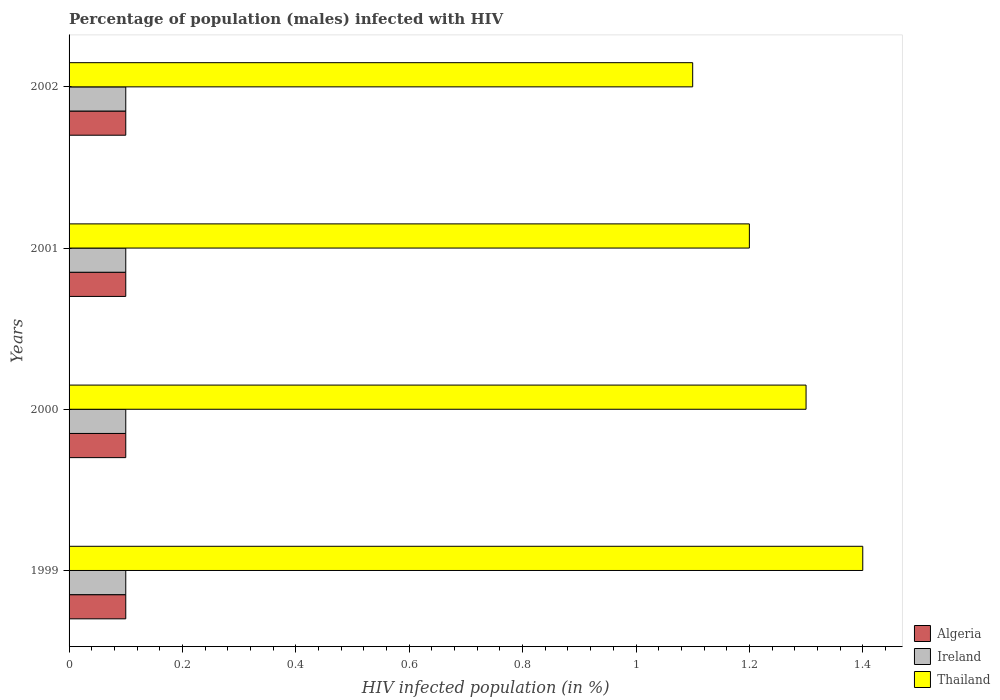How many groups of bars are there?
Ensure brevity in your answer.  4. How many bars are there on the 1st tick from the bottom?
Offer a terse response. 3. What is the label of the 2nd group of bars from the top?
Keep it short and to the point. 2001. Across all years, what is the minimum percentage of HIV infected male population in Algeria?
Your response must be concise. 0.1. In which year was the percentage of HIV infected male population in Thailand minimum?
Give a very brief answer. 2002. What is the difference between the percentage of HIV infected male population in Algeria in 2000 and the percentage of HIV infected male population in Ireland in 2001?
Give a very brief answer. 0. What is the ratio of the percentage of HIV infected male population in Thailand in 1999 to that in 2002?
Your answer should be compact. 1.27. Is the percentage of HIV infected male population in Ireland in 1999 less than that in 2002?
Provide a succinct answer. No. What is the difference between the highest and the lowest percentage of HIV infected male population in Ireland?
Give a very brief answer. 0. In how many years, is the percentage of HIV infected male population in Thailand greater than the average percentage of HIV infected male population in Thailand taken over all years?
Offer a terse response. 2. What does the 2nd bar from the top in 2001 represents?
Offer a terse response. Ireland. What does the 3rd bar from the bottom in 2001 represents?
Provide a succinct answer. Thailand. Is it the case that in every year, the sum of the percentage of HIV infected male population in Thailand and percentage of HIV infected male population in Ireland is greater than the percentage of HIV infected male population in Algeria?
Provide a succinct answer. Yes. Are all the bars in the graph horizontal?
Give a very brief answer. Yes. How many years are there in the graph?
Your answer should be very brief. 4. What is the difference between two consecutive major ticks on the X-axis?
Ensure brevity in your answer.  0.2. Does the graph contain any zero values?
Give a very brief answer. No. Does the graph contain grids?
Offer a very short reply. No. Where does the legend appear in the graph?
Your answer should be very brief. Bottom right. How many legend labels are there?
Make the answer very short. 3. What is the title of the graph?
Ensure brevity in your answer.  Percentage of population (males) infected with HIV. What is the label or title of the X-axis?
Keep it short and to the point. HIV infected population (in %). What is the HIV infected population (in %) of Algeria in 1999?
Make the answer very short. 0.1. What is the HIV infected population (in %) of Thailand in 1999?
Provide a short and direct response. 1.4. What is the HIV infected population (in %) of Algeria in 2000?
Make the answer very short. 0.1. What is the HIV infected population (in %) in Ireland in 2001?
Ensure brevity in your answer.  0.1. What is the HIV infected population (in %) of Thailand in 2001?
Your answer should be compact. 1.2. What is the HIV infected population (in %) in Thailand in 2002?
Give a very brief answer. 1.1. Across all years, what is the maximum HIV infected population (in %) in Algeria?
Provide a short and direct response. 0.1. Across all years, what is the maximum HIV infected population (in %) of Ireland?
Provide a succinct answer. 0.1. Across all years, what is the minimum HIV infected population (in %) in Algeria?
Your answer should be compact. 0.1. What is the total HIV infected population (in %) of Algeria in the graph?
Your response must be concise. 0.4. What is the difference between the HIV infected population (in %) in Ireland in 1999 and that in 2000?
Keep it short and to the point. 0. What is the difference between the HIV infected population (in %) of Ireland in 1999 and that in 2002?
Your answer should be very brief. 0. What is the difference between the HIV infected population (in %) in Ireland in 2000 and that in 2001?
Your answer should be very brief. 0. What is the difference between the HIV infected population (in %) of Algeria in 2000 and that in 2002?
Offer a very short reply. 0. What is the difference between the HIV infected population (in %) of Ireland in 2000 and that in 2002?
Provide a succinct answer. 0. What is the difference between the HIV infected population (in %) of Algeria in 2001 and that in 2002?
Your response must be concise. 0. What is the difference between the HIV infected population (in %) in Thailand in 2001 and that in 2002?
Give a very brief answer. 0.1. What is the difference between the HIV infected population (in %) of Algeria in 1999 and the HIV infected population (in %) of Thailand in 2001?
Offer a terse response. -1.1. What is the difference between the HIV infected population (in %) in Ireland in 1999 and the HIV infected population (in %) in Thailand in 2001?
Offer a terse response. -1.1. What is the difference between the HIV infected population (in %) in Algeria in 1999 and the HIV infected population (in %) in Ireland in 2002?
Offer a terse response. 0. What is the difference between the HIV infected population (in %) in Algeria in 1999 and the HIV infected population (in %) in Thailand in 2002?
Ensure brevity in your answer.  -1. What is the difference between the HIV infected population (in %) in Ireland in 2000 and the HIV infected population (in %) in Thailand in 2001?
Ensure brevity in your answer.  -1.1. What is the difference between the HIV infected population (in %) of Algeria in 2000 and the HIV infected population (in %) of Thailand in 2002?
Provide a succinct answer. -1. What is the difference between the HIV infected population (in %) in Algeria in 2001 and the HIV infected population (in %) in Thailand in 2002?
Keep it short and to the point. -1. What is the difference between the HIV infected population (in %) of Ireland in 2001 and the HIV infected population (in %) of Thailand in 2002?
Your answer should be very brief. -1. What is the average HIV infected population (in %) of Algeria per year?
Your answer should be very brief. 0.1. In the year 1999, what is the difference between the HIV infected population (in %) of Algeria and HIV infected population (in %) of Ireland?
Ensure brevity in your answer.  0. In the year 1999, what is the difference between the HIV infected population (in %) in Algeria and HIV infected population (in %) in Thailand?
Give a very brief answer. -1.3. In the year 1999, what is the difference between the HIV infected population (in %) of Ireland and HIV infected population (in %) of Thailand?
Provide a succinct answer. -1.3. In the year 2000, what is the difference between the HIV infected population (in %) in Algeria and HIV infected population (in %) in Thailand?
Keep it short and to the point. -1.2. In the year 2001, what is the difference between the HIV infected population (in %) of Ireland and HIV infected population (in %) of Thailand?
Provide a short and direct response. -1.1. In the year 2002, what is the difference between the HIV infected population (in %) of Algeria and HIV infected population (in %) of Thailand?
Your answer should be compact. -1. What is the ratio of the HIV infected population (in %) of Algeria in 1999 to that in 2001?
Offer a terse response. 1. What is the ratio of the HIV infected population (in %) in Ireland in 1999 to that in 2001?
Offer a terse response. 1. What is the ratio of the HIV infected population (in %) of Thailand in 1999 to that in 2001?
Provide a short and direct response. 1.17. What is the ratio of the HIV infected population (in %) of Ireland in 1999 to that in 2002?
Provide a short and direct response. 1. What is the ratio of the HIV infected population (in %) in Thailand in 1999 to that in 2002?
Make the answer very short. 1.27. What is the ratio of the HIV infected population (in %) of Algeria in 2000 to that in 2001?
Offer a very short reply. 1. What is the ratio of the HIV infected population (in %) in Algeria in 2000 to that in 2002?
Provide a succinct answer. 1. What is the ratio of the HIV infected population (in %) of Thailand in 2000 to that in 2002?
Offer a terse response. 1.18. What is the ratio of the HIV infected population (in %) of Algeria in 2001 to that in 2002?
Make the answer very short. 1. What is the ratio of the HIV infected population (in %) of Thailand in 2001 to that in 2002?
Offer a very short reply. 1.09. What is the difference between the highest and the second highest HIV infected population (in %) in Algeria?
Provide a succinct answer. 0. What is the difference between the highest and the second highest HIV infected population (in %) of Thailand?
Keep it short and to the point. 0.1. 